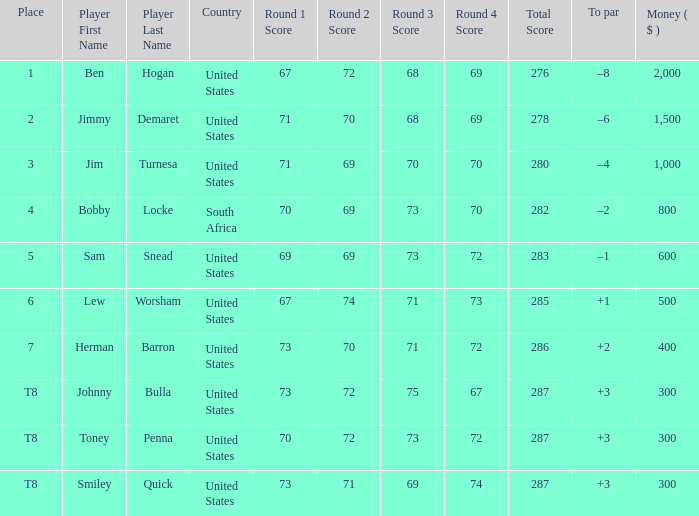What is the Score of the game of the Player in Place 4? 70-69-73-70=282. 